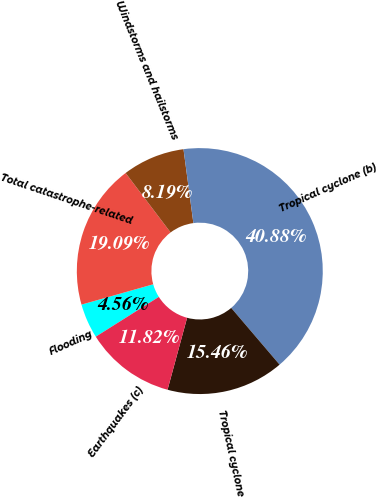Convert chart. <chart><loc_0><loc_0><loc_500><loc_500><pie_chart><fcel>Flooding<fcel>Total catastrophe-related<fcel>Windstorms and hailstorms<fcel>Tropical cyclone (b)<fcel>Tropical cyclone<fcel>Earthquakes (c)<nl><fcel>4.56%<fcel>19.09%<fcel>8.19%<fcel>40.88%<fcel>15.46%<fcel>11.82%<nl></chart> 